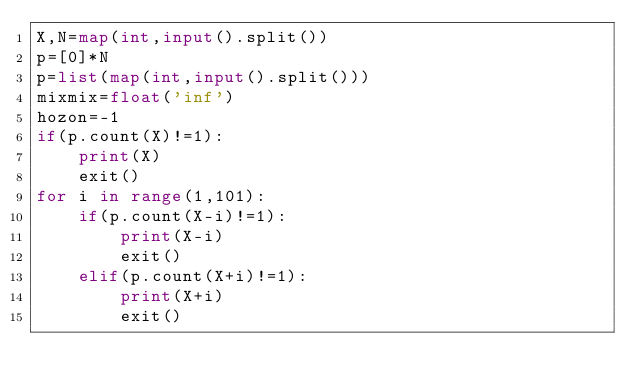Convert code to text. <code><loc_0><loc_0><loc_500><loc_500><_Python_>X,N=map(int,input().split())
p=[0]*N
p=list(map(int,input().split()))
mixmix=float('inf')
hozon=-1
if(p.count(X)!=1):
    print(X)
    exit()
for i in range(1,101):
    if(p.count(X-i)!=1):
        print(X-i)
        exit()
    elif(p.count(X+i)!=1):
        print(X+i)
        exit()</code> 